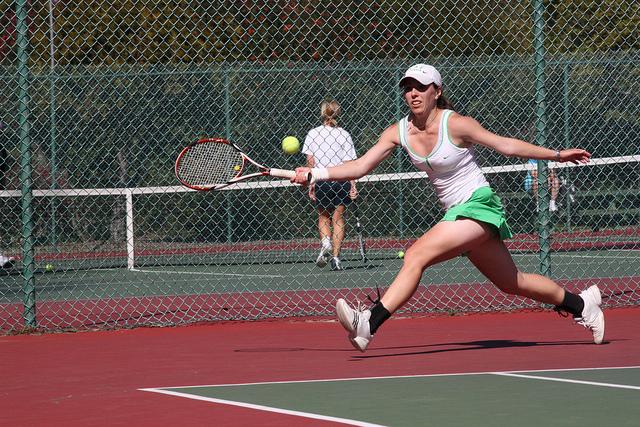What is the woman hitting?
Answer briefly. Tennis ball. What game is this?
Short answer required. Tennis. Is the woman walking towards the ball?
Answer briefly. No. 